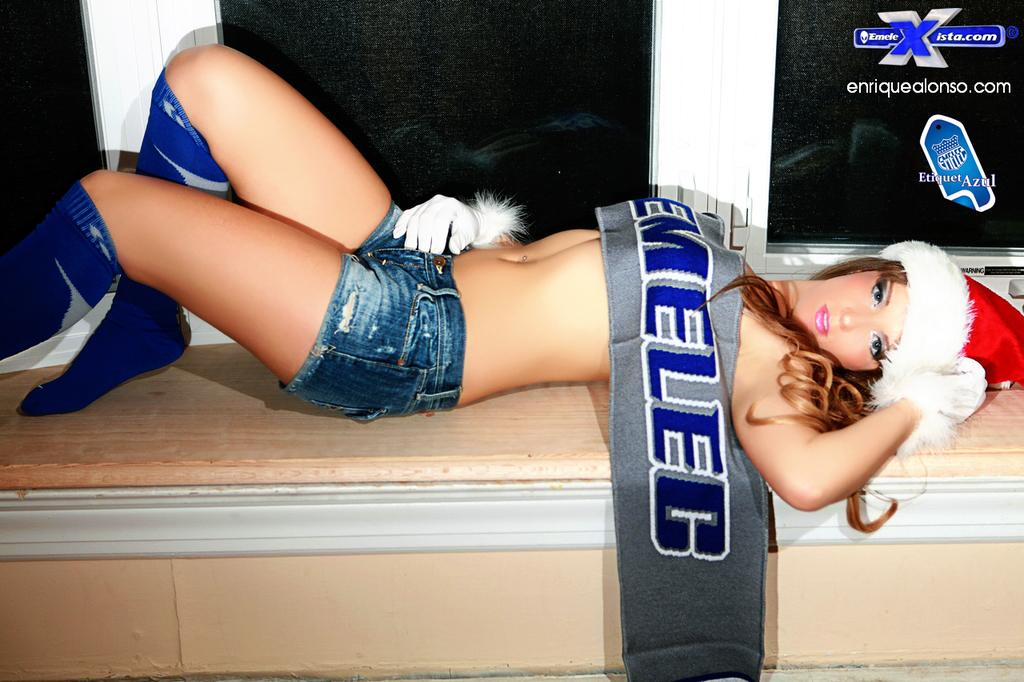<image>
Describe the image concisely. an enriquealonso ad next to a lady scantily clad. 